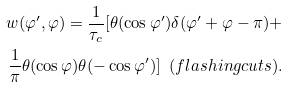Convert formula to latex. <formula><loc_0><loc_0><loc_500><loc_500>w ( \varphi ^ { \prime } , \varphi ) = \frac { 1 } { \tau _ { c } } [ \theta ( \cos \varphi ^ { \prime } ) \delta ( \varphi ^ { \prime } + \varphi - \pi ) + \\ \frac { 1 } { \pi } \theta ( \cos \varphi ) \theta ( - \cos \varphi ^ { \prime } ) ] \ \ ( f l a s h i n g c u t s ) .</formula> 